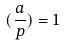Convert formula to latex. <formula><loc_0><loc_0><loc_500><loc_500>( \frac { a } { p } ) = 1</formula> 